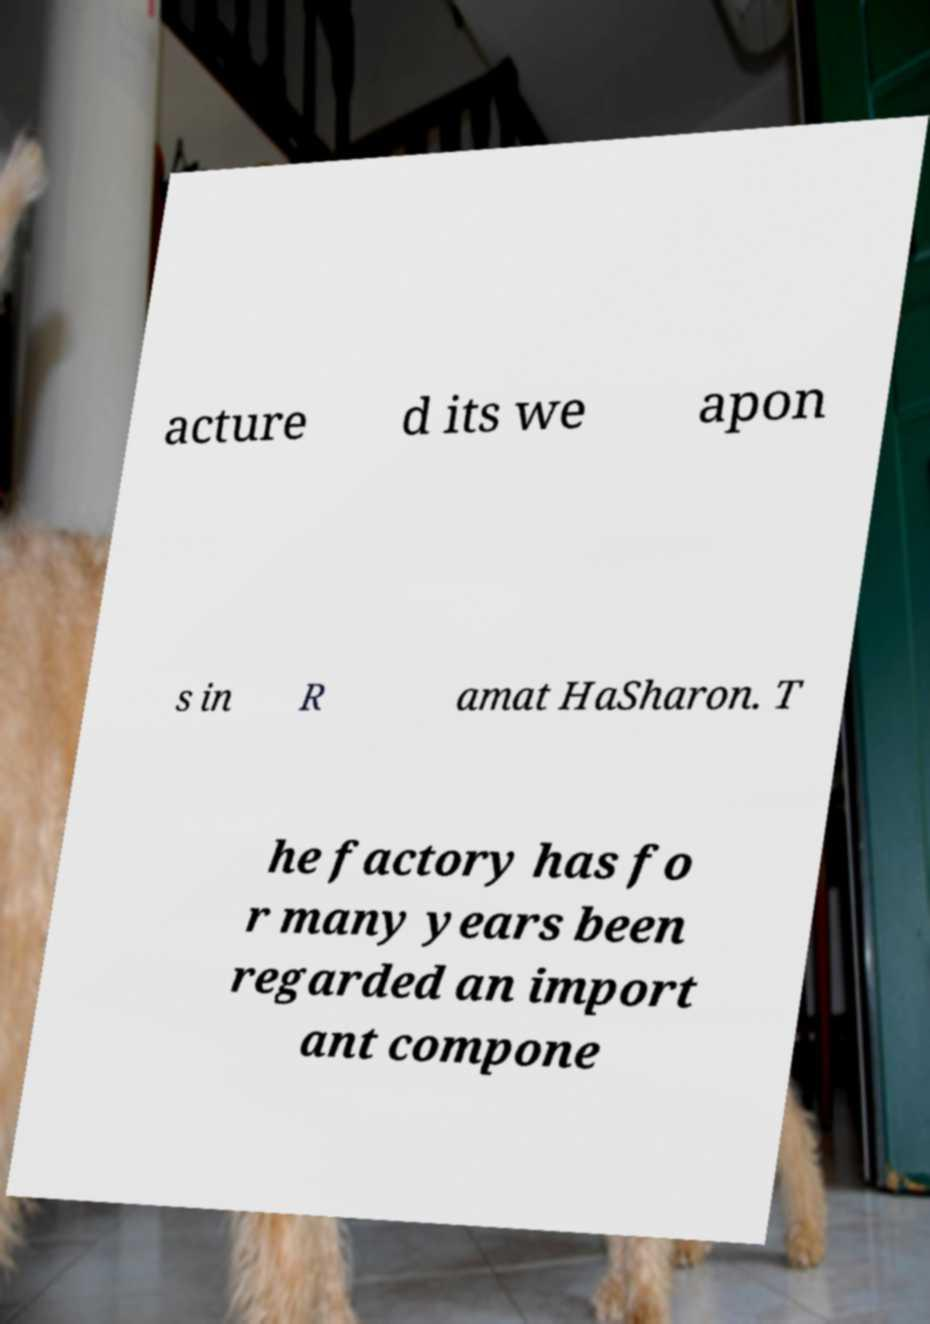Can you read and provide the text displayed in the image?This photo seems to have some interesting text. Can you extract and type it out for me? acture d its we apon s in R amat HaSharon. T he factory has fo r many years been regarded an import ant compone 